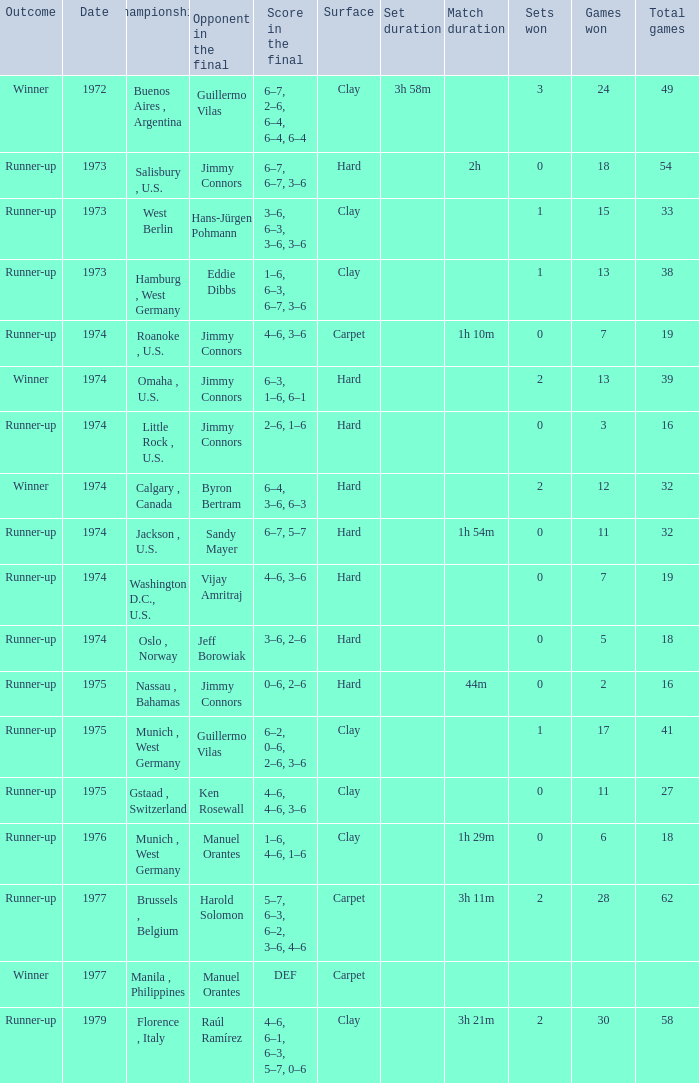What was the final score with Guillermo Vilas as the opponent in the final, that happened after 1972? 6–2, 0–6, 2–6, 3–6. 